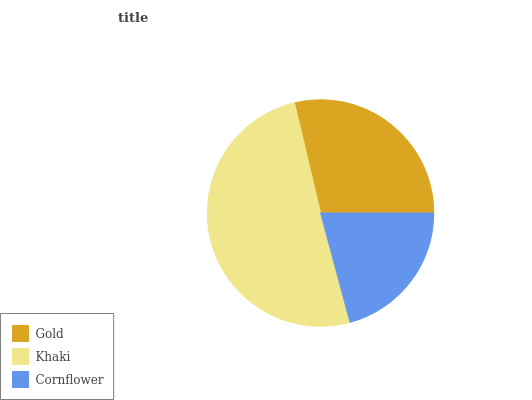Is Cornflower the minimum?
Answer yes or no. Yes. Is Khaki the maximum?
Answer yes or no. Yes. Is Khaki the minimum?
Answer yes or no. No. Is Cornflower the maximum?
Answer yes or no. No. Is Khaki greater than Cornflower?
Answer yes or no. Yes. Is Cornflower less than Khaki?
Answer yes or no. Yes. Is Cornflower greater than Khaki?
Answer yes or no. No. Is Khaki less than Cornflower?
Answer yes or no. No. Is Gold the high median?
Answer yes or no. Yes. Is Gold the low median?
Answer yes or no. Yes. Is Cornflower the high median?
Answer yes or no. No. Is Khaki the low median?
Answer yes or no. No. 